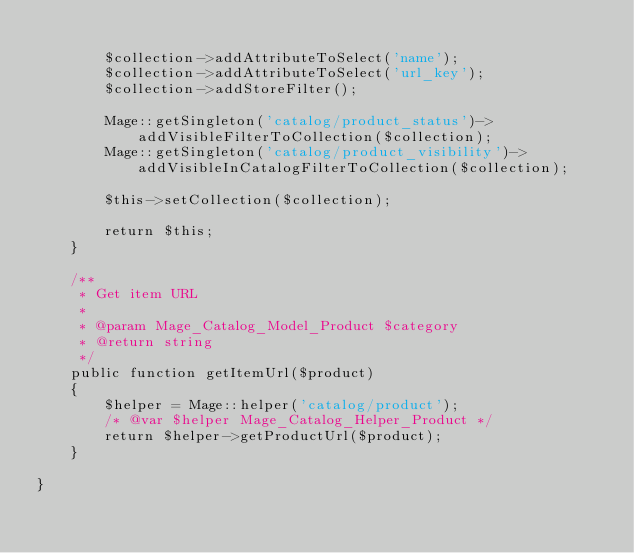<code> <loc_0><loc_0><loc_500><loc_500><_PHP_>
        $collection->addAttributeToSelect('name');
        $collection->addAttributeToSelect('url_key');
        $collection->addStoreFilter();

        Mage::getSingleton('catalog/product_status')->addVisibleFilterToCollection($collection);
        Mage::getSingleton('catalog/product_visibility')->addVisibleInCatalogFilterToCollection($collection);

        $this->setCollection($collection);

        return $this;
    }

    /**
     * Get item URL
     *
     * @param Mage_Catalog_Model_Product $category
     * @return string
     */
    public function getItemUrl($product)
    {
        $helper = Mage::helper('catalog/product');
        /* @var $helper Mage_Catalog_Helper_Product */
        return $helper->getProductUrl($product);
    }

}
</code> 